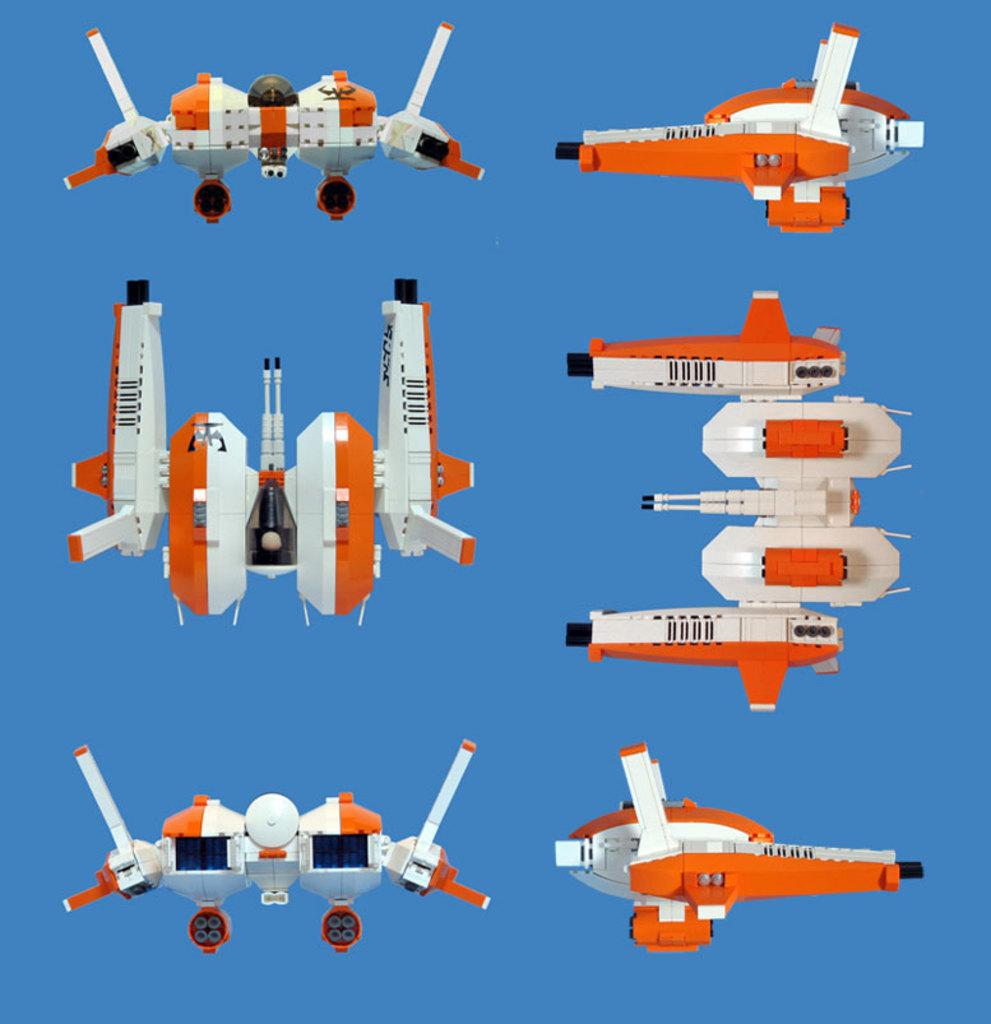What types of objects are present in the image? There are gadgets in the image. What color is the background of the image? The background of the image is blue. Can you tell me how many records are visible in the image? There are no records present in the image; it features gadgets and a blue background. What type of meat is being cooked in the image? There is no meat or cooking activity present in the image. 